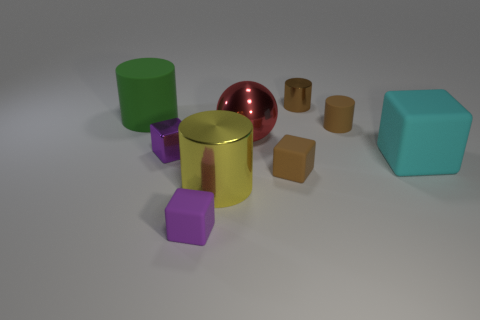How many other blocks are the same color as the small metallic cube?
Your response must be concise. 1. There is a small block that is right of the large red object; does it have the same color as the tiny thing that is right of the small shiny cylinder?
Provide a succinct answer. Yes. Are there any shiny things on the left side of the red shiny object?
Your answer should be compact. Yes. What material is the cyan block?
Give a very brief answer. Rubber. There is a small purple matte thing that is left of the red thing; what is its shape?
Keep it short and to the point. Cube. Are there any cylinders of the same size as the purple shiny object?
Your answer should be very brief. Yes. Do the purple cube that is behind the yellow shiny thing and the big cyan block have the same material?
Ensure brevity in your answer.  No. Are there an equal number of small brown blocks on the left side of the big metal ball and big red metallic balls that are behind the small brown shiny thing?
Your response must be concise. Yes. There is a brown thing that is to the left of the tiny brown rubber cylinder and in front of the green matte cylinder; what is its shape?
Offer a very short reply. Cube. How many big cyan objects are in front of the cyan cube?
Ensure brevity in your answer.  0. 